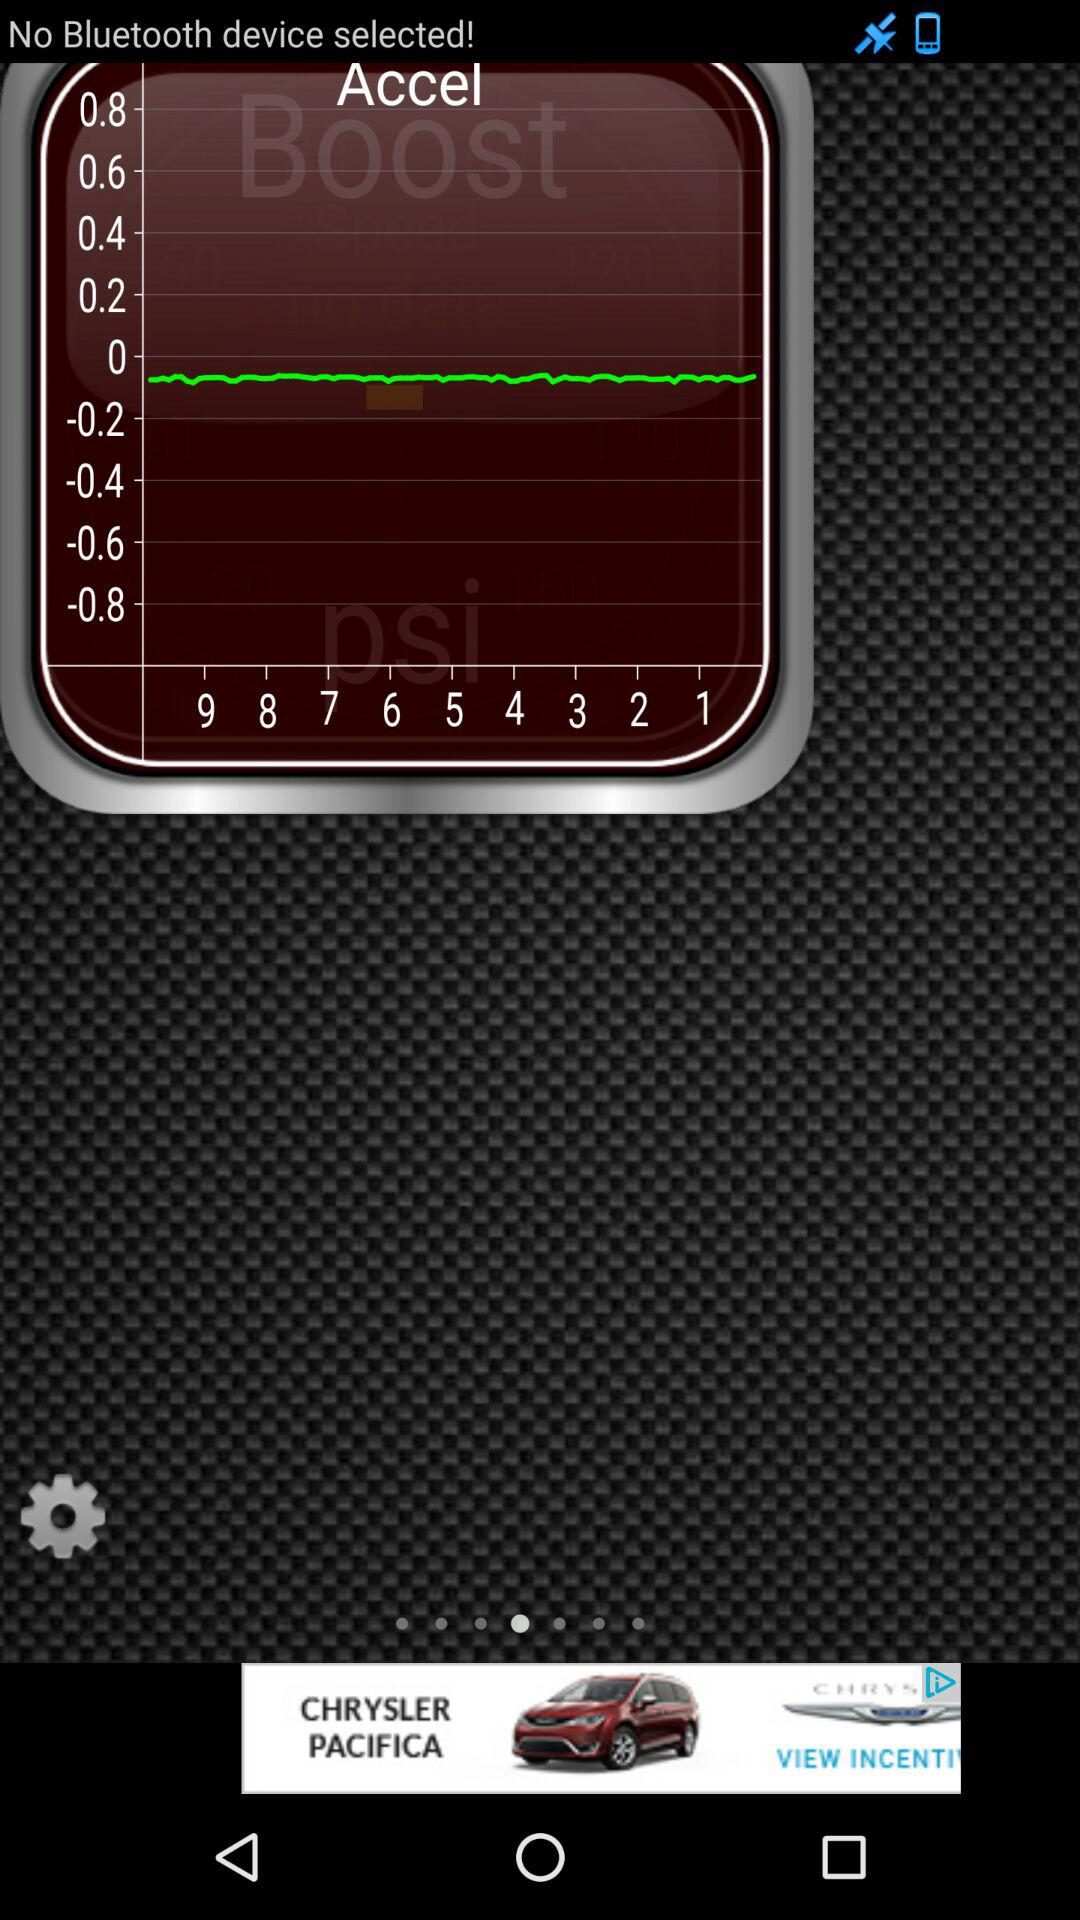How many times does the text 'No Bluetooth device selected!' appear on the screen?
Answer the question using a single word or phrase. 1 